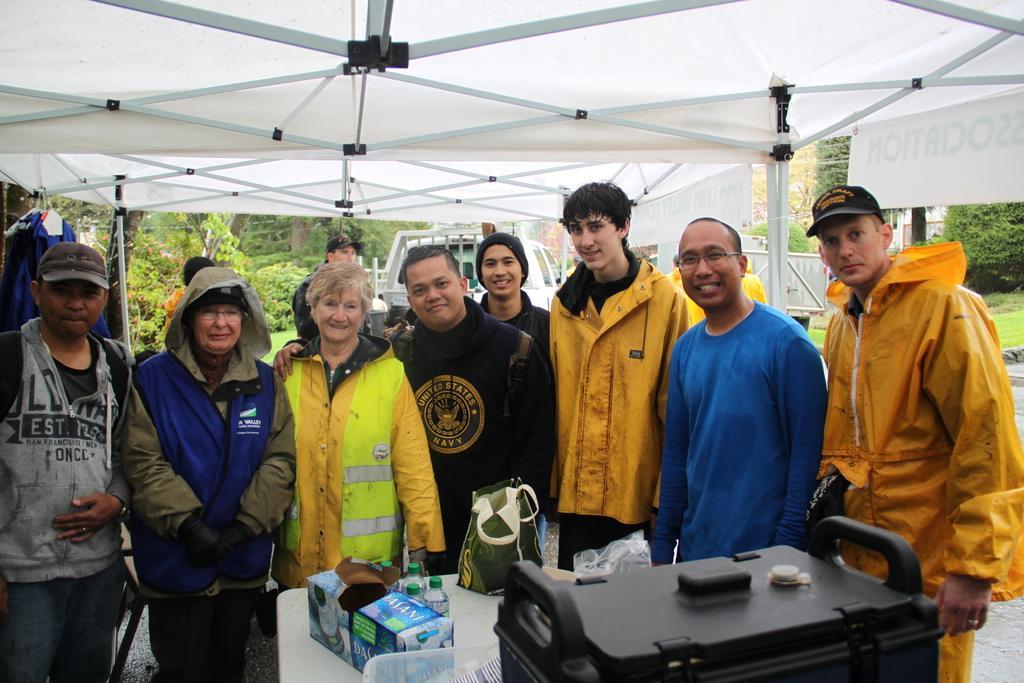How would you summarize this image in a sentence or two? In this image we can see there are people standing under the tent and we can see the table, on the table there are boxes, bag, bottles and a few objects. And at the back we can see the trees, grass and vehicles. 